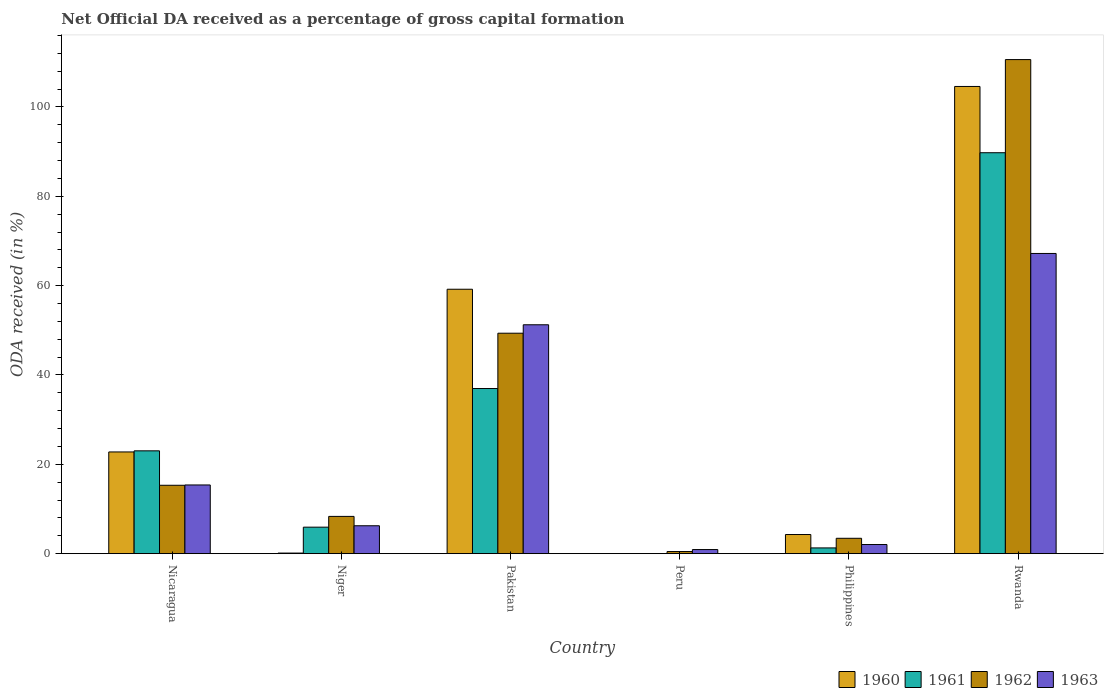How many different coloured bars are there?
Keep it short and to the point. 4. How many groups of bars are there?
Your response must be concise. 6. Are the number of bars per tick equal to the number of legend labels?
Offer a very short reply. No. How many bars are there on the 4th tick from the right?
Provide a short and direct response. 4. What is the label of the 1st group of bars from the left?
Provide a succinct answer. Nicaragua. In how many cases, is the number of bars for a given country not equal to the number of legend labels?
Give a very brief answer. 1. What is the net ODA received in 1963 in Philippines?
Offer a very short reply. 2.05. Across all countries, what is the maximum net ODA received in 1963?
Make the answer very short. 67.2. Across all countries, what is the minimum net ODA received in 1961?
Offer a terse response. 0. In which country was the net ODA received in 1961 maximum?
Keep it short and to the point. Rwanda. What is the total net ODA received in 1961 in the graph?
Offer a very short reply. 156.95. What is the difference between the net ODA received in 1963 in Nicaragua and that in Philippines?
Ensure brevity in your answer.  13.33. What is the difference between the net ODA received in 1961 in Philippines and the net ODA received in 1960 in Rwanda?
Your answer should be very brief. -103.3. What is the average net ODA received in 1963 per country?
Offer a very short reply. 23.84. What is the difference between the net ODA received of/in 1963 and net ODA received of/in 1961 in Nicaragua?
Offer a very short reply. -7.64. What is the ratio of the net ODA received in 1962 in Nicaragua to that in Rwanda?
Keep it short and to the point. 0.14. Is the net ODA received in 1963 in Pakistan less than that in Rwanda?
Your answer should be very brief. Yes. What is the difference between the highest and the second highest net ODA received in 1962?
Offer a terse response. -61.25. What is the difference between the highest and the lowest net ODA received in 1962?
Offer a terse response. 110.13. Is it the case that in every country, the sum of the net ODA received in 1961 and net ODA received in 1962 is greater than the sum of net ODA received in 1963 and net ODA received in 1960?
Provide a succinct answer. No. Is it the case that in every country, the sum of the net ODA received in 1961 and net ODA received in 1962 is greater than the net ODA received in 1963?
Offer a terse response. No. How many bars are there?
Keep it short and to the point. 22. Are all the bars in the graph horizontal?
Keep it short and to the point. No. How many countries are there in the graph?
Your answer should be very brief. 6. Are the values on the major ticks of Y-axis written in scientific E-notation?
Your response must be concise. No. Does the graph contain grids?
Make the answer very short. No. What is the title of the graph?
Your answer should be very brief. Net Official DA received as a percentage of gross capital formation. Does "1980" appear as one of the legend labels in the graph?
Your answer should be compact. No. What is the label or title of the X-axis?
Provide a succinct answer. Country. What is the label or title of the Y-axis?
Offer a very short reply. ODA received (in %). What is the ODA received (in %) of 1960 in Nicaragua?
Your answer should be compact. 22.77. What is the ODA received (in %) of 1961 in Nicaragua?
Offer a very short reply. 23.02. What is the ODA received (in %) of 1962 in Nicaragua?
Your answer should be very brief. 15.31. What is the ODA received (in %) in 1963 in Nicaragua?
Your response must be concise. 15.38. What is the ODA received (in %) in 1960 in Niger?
Provide a succinct answer. 0.13. What is the ODA received (in %) in 1961 in Niger?
Give a very brief answer. 5.93. What is the ODA received (in %) of 1962 in Niger?
Ensure brevity in your answer.  8.34. What is the ODA received (in %) in 1963 in Niger?
Provide a succinct answer. 6.25. What is the ODA received (in %) in 1960 in Pakistan?
Your answer should be compact. 59.19. What is the ODA received (in %) in 1961 in Pakistan?
Keep it short and to the point. 36.96. What is the ODA received (in %) of 1962 in Pakistan?
Provide a succinct answer. 49.35. What is the ODA received (in %) in 1963 in Pakistan?
Your answer should be compact. 51.24. What is the ODA received (in %) in 1962 in Peru?
Make the answer very short. 0.47. What is the ODA received (in %) of 1963 in Peru?
Provide a short and direct response. 0.92. What is the ODA received (in %) in 1960 in Philippines?
Ensure brevity in your answer.  4.28. What is the ODA received (in %) of 1961 in Philippines?
Make the answer very short. 1.29. What is the ODA received (in %) in 1962 in Philippines?
Provide a short and direct response. 3.44. What is the ODA received (in %) of 1963 in Philippines?
Give a very brief answer. 2.05. What is the ODA received (in %) in 1960 in Rwanda?
Make the answer very short. 104.58. What is the ODA received (in %) of 1961 in Rwanda?
Keep it short and to the point. 89.75. What is the ODA received (in %) of 1962 in Rwanda?
Your answer should be very brief. 110.6. What is the ODA received (in %) of 1963 in Rwanda?
Your answer should be compact. 67.2. Across all countries, what is the maximum ODA received (in %) of 1960?
Your answer should be very brief. 104.58. Across all countries, what is the maximum ODA received (in %) of 1961?
Make the answer very short. 89.75. Across all countries, what is the maximum ODA received (in %) of 1962?
Your answer should be compact. 110.6. Across all countries, what is the maximum ODA received (in %) of 1963?
Give a very brief answer. 67.2. Across all countries, what is the minimum ODA received (in %) in 1962?
Make the answer very short. 0.47. Across all countries, what is the minimum ODA received (in %) in 1963?
Provide a succinct answer. 0.92. What is the total ODA received (in %) of 1960 in the graph?
Offer a very short reply. 190.96. What is the total ODA received (in %) of 1961 in the graph?
Keep it short and to the point. 156.95. What is the total ODA received (in %) in 1962 in the graph?
Ensure brevity in your answer.  187.51. What is the total ODA received (in %) of 1963 in the graph?
Your answer should be very brief. 143.02. What is the difference between the ODA received (in %) of 1960 in Nicaragua and that in Niger?
Provide a succinct answer. 22.64. What is the difference between the ODA received (in %) in 1961 in Nicaragua and that in Niger?
Provide a succinct answer. 17.09. What is the difference between the ODA received (in %) in 1962 in Nicaragua and that in Niger?
Provide a succinct answer. 6.97. What is the difference between the ODA received (in %) in 1963 in Nicaragua and that in Niger?
Offer a terse response. 9.13. What is the difference between the ODA received (in %) of 1960 in Nicaragua and that in Pakistan?
Offer a very short reply. -36.42. What is the difference between the ODA received (in %) in 1961 in Nicaragua and that in Pakistan?
Your answer should be very brief. -13.95. What is the difference between the ODA received (in %) in 1962 in Nicaragua and that in Pakistan?
Provide a succinct answer. -34.04. What is the difference between the ODA received (in %) of 1963 in Nicaragua and that in Pakistan?
Your answer should be compact. -35.86. What is the difference between the ODA received (in %) in 1962 in Nicaragua and that in Peru?
Provide a short and direct response. 14.83. What is the difference between the ODA received (in %) of 1963 in Nicaragua and that in Peru?
Your answer should be very brief. 14.46. What is the difference between the ODA received (in %) of 1960 in Nicaragua and that in Philippines?
Your response must be concise. 18.48. What is the difference between the ODA received (in %) of 1961 in Nicaragua and that in Philippines?
Offer a very short reply. 21.73. What is the difference between the ODA received (in %) in 1962 in Nicaragua and that in Philippines?
Your answer should be very brief. 11.87. What is the difference between the ODA received (in %) in 1963 in Nicaragua and that in Philippines?
Offer a terse response. 13.33. What is the difference between the ODA received (in %) of 1960 in Nicaragua and that in Rwanda?
Provide a succinct answer. -81.81. What is the difference between the ODA received (in %) in 1961 in Nicaragua and that in Rwanda?
Your answer should be very brief. -66.73. What is the difference between the ODA received (in %) in 1962 in Nicaragua and that in Rwanda?
Provide a short and direct response. -95.29. What is the difference between the ODA received (in %) of 1963 in Nicaragua and that in Rwanda?
Offer a terse response. -51.82. What is the difference between the ODA received (in %) in 1960 in Niger and that in Pakistan?
Provide a short and direct response. -59.06. What is the difference between the ODA received (in %) of 1961 in Niger and that in Pakistan?
Keep it short and to the point. -31.03. What is the difference between the ODA received (in %) of 1962 in Niger and that in Pakistan?
Provide a short and direct response. -41.01. What is the difference between the ODA received (in %) in 1963 in Niger and that in Pakistan?
Your answer should be compact. -44.99. What is the difference between the ODA received (in %) of 1962 in Niger and that in Peru?
Your answer should be very brief. 7.87. What is the difference between the ODA received (in %) in 1963 in Niger and that in Peru?
Ensure brevity in your answer.  5.33. What is the difference between the ODA received (in %) in 1960 in Niger and that in Philippines?
Keep it short and to the point. -4.15. What is the difference between the ODA received (in %) of 1961 in Niger and that in Philippines?
Offer a very short reply. 4.64. What is the difference between the ODA received (in %) in 1962 in Niger and that in Philippines?
Provide a short and direct response. 4.9. What is the difference between the ODA received (in %) of 1963 in Niger and that in Philippines?
Your answer should be compact. 4.2. What is the difference between the ODA received (in %) in 1960 in Niger and that in Rwanda?
Make the answer very short. -104.45. What is the difference between the ODA received (in %) in 1961 in Niger and that in Rwanda?
Give a very brief answer. -83.82. What is the difference between the ODA received (in %) in 1962 in Niger and that in Rwanda?
Give a very brief answer. -102.26. What is the difference between the ODA received (in %) of 1963 in Niger and that in Rwanda?
Your answer should be compact. -60.95. What is the difference between the ODA received (in %) in 1962 in Pakistan and that in Peru?
Make the answer very short. 48.87. What is the difference between the ODA received (in %) of 1963 in Pakistan and that in Peru?
Offer a terse response. 50.32. What is the difference between the ODA received (in %) of 1960 in Pakistan and that in Philippines?
Provide a succinct answer. 54.9. What is the difference between the ODA received (in %) of 1961 in Pakistan and that in Philippines?
Ensure brevity in your answer.  35.68. What is the difference between the ODA received (in %) of 1962 in Pakistan and that in Philippines?
Keep it short and to the point. 45.91. What is the difference between the ODA received (in %) of 1963 in Pakistan and that in Philippines?
Your answer should be compact. 49.19. What is the difference between the ODA received (in %) in 1960 in Pakistan and that in Rwanda?
Offer a terse response. -45.39. What is the difference between the ODA received (in %) of 1961 in Pakistan and that in Rwanda?
Make the answer very short. -52.79. What is the difference between the ODA received (in %) in 1962 in Pakistan and that in Rwanda?
Ensure brevity in your answer.  -61.25. What is the difference between the ODA received (in %) in 1963 in Pakistan and that in Rwanda?
Your answer should be very brief. -15.96. What is the difference between the ODA received (in %) of 1962 in Peru and that in Philippines?
Make the answer very short. -2.97. What is the difference between the ODA received (in %) of 1963 in Peru and that in Philippines?
Give a very brief answer. -1.13. What is the difference between the ODA received (in %) in 1962 in Peru and that in Rwanda?
Provide a short and direct response. -110.13. What is the difference between the ODA received (in %) in 1963 in Peru and that in Rwanda?
Provide a succinct answer. -66.28. What is the difference between the ODA received (in %) in 1960 in Philippines and that in Rwanda?
Provide a short and direct response. -100.3. What is the difference between the ODA received (in %) of 1961 in Philippines and that in Rwanda?
Offer a terse response. -88.46. What is the difference between the ODA received (in %) in 1962 in Philippines and that in Rwanda?
Provide a succinct answer. -107.16. What is the difference between the ODA received (in %) of 1963 in Philippines and that in Rwanda?
Provide a succinct answer. -65.15. What is the difference between the ODA received (in %) of 1960 in Nicaragua and the ODA received (in %) of 1961 in Niger?
Offer a very short reply. 16.84. What is the difference between the ODA received (in %) in 1960 in Nicaragua and the ODA received (in %) in 1962 in Niger?
Your answer should be compact. 14.43. What is the difference between the ODA received (in %) in 1960 in Nicaragua and the ODA received (in %) in 1963 in Niger?
Make the answer very short. 16.52. What is the difference between the ODA received (in %) in 1961 in Nicaragua and the ODA received (in %) in 1962 in Niger?
Keep it short and to the point. 14.68. What is the difference between the ODA received (in %) of 1961 in Nicaragua and the ODA received (in %) of 1963 in Niger?
Provide a succinct answer. 16.77. What is the difference between the ODA received (in %) in 1962 in Nicaragua and the ODA received (in %) in 1963 in Niger?
Offer a terse response. 9.06. What is the difference between the ODA received (in %) of 1960 in Nicaragua and the ODA received (in %) of 1961 in Pakistan?
Make the answer very short. -14.2. What is the difference between the ODA received (in %) of 1960 in Nicaragua and the ODA received (in %) of 1962 in Pakistan?
Keep it short and to the point. -26.58. What is the difference between the ODA received (in %) of 1960 in Nicaragua and the ODA received (in %) of 1963 in Pakistan?
Your response must be concise. -28.47. What is the difference between the ODA received (in %) in 1961 in Nicaragua and the ODA received (in %) in 1962 in Pakistan?
Make the answer very short. -26.33. What is the difference between the ODA received (in %) in 1961 in Nicaragua and the ODA received (in %) in 1963 in Pakistan?
Provide a short and direct response. -28.22. What is the difference between the ODA received (in %) in 1962 in Nicaragua and the ODA received (in %) in 1963 in Pakistan?
Your response must be concise. -35.93. What is the difference between the ODA received (in %) in 1960 in Nicaragua and the ODA received (in %) in 1962 in Peru?
Provide a short and direct response. 22.29. What is the difference between the ODA received (in %) in 1960 in Nicaragua and the ODA received (in %) in 1963 in Peru?
Your answer should be very brief. 21.85. What is the difference between the ODA received (in %) of 1961 in Nicaragua and the ODA received (in %) of 1962 in Peru?
Provide a succinct answer. 22.54. What is the difference between the ODA received (in %) of 1961 in Nicaragua and the ODA received (in %) of 1963 in Peru?
Ensure brevity in your answer.  22.1. What is the difference between the ODA received (in %) in 1962 in Nicaragua and the ODA received (in %) in 1963 in Peru?
Offer a terse response. 14.39. What is the difference between the ODA received (in %) in 1960 in Nicaragua and the ODA received (in %) in 1961 in Philippines?
Keep it short and to the point. 21.48. What is the difference between the ODA received (in %) in 1960 in Nicaragua and the ODA received (in %) in 1962 in Philippines?
Give a very brief answer. 19.33. What is the difference between the ODA received (in %) of 1960 in Nicaragua and the ODA received (in %) of 1963 in Philippines?
Your answer should be very brief. 20.72. What is the difference between the ODA received (in %) in 1961 in Nicaragua and the ODA received (in %) in 1962 in Philippines?
Your answer should be very brief. 19.58. What is the difference between the ODA received (in %) of 1961 in Nicaragua and the ODA received (in %) of 1963 in Philippines?
Your response must be concise. 20.97. What is the difference between the ODA received (in %) of 1962 in Nicaragua and the ODA received (in %) of 1963 in Philippines?
Offer a terse response. 13.26. What is the difference between the ODA received (in %) of 1960 in Nicaragua and the ODA received (in %) of 1961 in Rwanda?
Offer a terse response. -66.98. What is the difference between the ODA received (in %) in 1960 in Nicaragua and the ODA received (in %) in 1962 in Rwanda?
Ensure brevity in your answer.  -87.83. What is the difference between the ODA received (in %) of 1960 in Nicaragua and the ODA received (in %) of 1963 in Rwanda?
Give a very brief answer. -44.43. What is the difference between the ODA received (in %) of 1961 in Nicaragua and the ODA received (in %) of 1962 in Rwanda?
Ensure brevity in your answer.  -87.58. What is the difference between the ODA received (in %) of 1961 in Nicaragua and the ODA received (in %) of 1963 in Rwanda?
Your answer should be compact. -44.18. What is the difference between the ODA received (in %) in 1962 in Nicaragua and the ODA received (in %) in 1963 in Rwanda?
Your answer should be very brief. -51.89. What is the difference between the ODA received (in %) of 1960 in Niger and the ODA received (in %) of 1961 in Pakistan?
Provide a succinct answer. -36.83. What is the difference between the ODA received (in %) of 1960 in Niger and the ODA received (in %) of 1962 in Pakistan?
Your answer should be very brief. -49.21. What is the difference between the ODA received (in %) in 1960 in Niger and the ODA received (in %) in 1963 in Pakistan?
Keep it short and to the point. -51.1. What is the difference between the ODA received (in %) in 1961 in Niger and the ODA received (in %) in 1962 in Pakistan?
Provide a short and direct response. -43.42. What is the difference between the ODA received (in %) in 1961 in Niger and the ODA received (in %) in 1963 in Pakistan?
Keep it short and to the point. -45.31. What is the difference between the ODA received (in %) in 1962 in Niger and the ODA received (in %) in 1963 in Pakistan?
Provide a short and direct response. -42.9. What is the difference between the ODA received (in %) in 1960 in Niger and the ODA received (in %) in 1962 in Peru?
Your response must be concise. -0.34. What is the difference between the ODA received (in %) of 1960 in Niger and the ODA received (in %) of 1963 in Peru?
Your answer should be compact. -0.78. What is the difference between the ODA received (in %) of 1961 in Niger and the ODA received (in %) of 1962 in Peru?
Ensure brevity in your answer.  5.46. What is the difference between the ODA received (in %) of 1961 in Niger and the ODA received (in %) of 1963 in Peru?
Make the answer very short. 5.01. What is the difference between the ODA received (in %) in 1962 in Niger and the ODA received (in %) in 1963 in Peru?
Provide a short and direct response. 7.42. What is the difference between the ODA received (in %) in 1960 in Niger and the ODA received (in %) in 1961 in Philippines?
Offer a terse response. -1.15. What is the difference between the ODA received (in %) in 1960 in Niger and the ODA received (in %) in 1962 in Philippines?
Your answer should be very brief. -3.31. What is the difference between the ODA received (in %) in 1960 in Niger and the ODA received (in %) in 1963 in Philippines?
Offer a terse response. -1.91. What is the difference between the ODA received (in %) in 1961 in Niger and the ODA received (in %) in 1962 in Philippines?
Give a very brief answer. 2.49. What is the difference between the ODA received (in %) in 1961 in Niger and the ODA received (in %) in 1963 in Philippines?
Keep it short and to the point. 3.88. What is the difference between the ODA received (in %) in 1962 in Niger and the ODA received (in %) in 1963 in Philippines?
Provide a short and direct response. 6.29. What is the difference between the ODA received (in %) in 1960 in Niger and the ODA received (in %) in 1961 in Rwanda?
Offer a terse response. -89.62. What is the difference between the ODA received (in %) in 1960 in Niger and the ODA received (in %) in 1962 in Rwanda?
Keep it short and to the point. -110.47. What is the difference between the ODA received (in %) in 1960 in Niger and the ODA received (in %) in 1963 in Rwanda?
Your answer should be compact. -67.07. What is the difference between the ODA received (in %) in 1961 in Niger and the ODA received (in %) in 1962 in Rwanda?
Offer a very short reply. -104.67. What is the difference between the ODA received (in %) of 1961 in Niger and the ODA received (in %) of 1963 in Rwanda?
Provide a short and direct response. -61.27. What is the difference between the ODA received (in %) in 1962 in Niger and the ODA received (in %) in 1963 in Rwanda?
Provide a short and direct response. -58.86. What is the difference between the ODA received (in %) in 1960 in Pakistan and the ODA received (in %) in 1962 in Peru?
Provide a short and direct response. 58.71. What is the difference between the ODA received (in %) in 1960 in Pakistan and the ODA received (in %) in 1963 in Peru?
Provide a succinct answer. 58.27. What is the difference between the ODA received (in %) of 1961 in Pakistan and the ODA received (in %) of 1962 in Peru?
Your answer should be compact. 36.49. What is the difference between the ODA received (in %) of 1961 in Pakistan and the ODA received (in %) of 1963 in Peru?
Provide a succinct answer. 36.05. What is the difference between the ODA received (in %) of 1962 in Pakistan and the ODA received (in %) of 1963 in Peru?
Offer a terse response. 48.43. What is the difference between the ODA received (in %) of 1960 in Pakistan and the ODA received (in %) of 1961 in Philippines?
Provide a short and direct response. 57.9. What is the difference between the ODA received (in %) of 1960 in Pakistan and the ODA received (in %) of 1962 in Philippines?
Your response must be concise. 55.75. What is the difference between the ODA received (in %) of 1960 in Pakistan and the ODA received (in %) of 1963 in Philippines?
Provide a short and direct response. 57.14. What is the difference between the ODA received (in %) of 1961 in Pakistan and the ODA received (in %) of 1962 in Philippines?
Give a very brief answer. 33.52. What is the difference between the ODA received (in %) of 1961 in Pakistan and the ODA received (in %) of 1963 in Philippines?
Give a very brief answer. 34.92. What is the difference between the ODA received (in %) in 1962 in Pakistan and the ODA received (in %) in 1963 in Philippines?
Offer a very short reply. 47.3. What is the difference between the ODA received (in %) in 1960 in Pakistan and the ODA received (in %) in 1961 in Rwanda?
Offer a terse response. -30.56. What is the difference between the ODA received (in %) in 1960 in Pakistan and the ODA received (in %) in 1962 in Rwanda?
Your answer should be very brief. -51.41. What is the difference between the ODA received (in %) in 1960 in Pakistan and the ODA received (in %) in 1963 in Rwanda?
Offer a very short reply. -8.01. What is the difference between the ODA received (in %) in 1961 in Pakistan and the ODA received (in %) in 1962 in Rwanda?
Offer a very short reply. -73.64. What is the difference between the ODA received (in %) of 1961 in Pakistan and the ODA received (in %) of 1963 in Rwanda?
Give a very brief answer. -30.24. What is the difference between the ODA received (in %) in 1962 in Pakistan and the ODA received (in %) in 1963 in Rwanda?
Offer a very short reply. -17.85. What is the difference between the ODA received (in %) in 1962 in Peru and the ODA received (in %) in 1963 in Philippines?
Your response must be concise. -1.57. What is the difference between the ODA received (in %) of 1962 in Peru and the ODA received (in %) of 1963 in Rwanda?
Your response must be concise. -66.73. What is the difference between the ODA received (in %) in 1960 in Philippines and the ODA received (in %) in 1961 in Rwanda?
Provide a short and direct response. -85.47. What is the difference between the ODA received (in %) of 1960 in Philippines and the ODA received (in %) of 1962 in Rwanda?
Ensure brevity in your answer.  -106.32. What is the difference between the ODA received (in %) in 1960 in Philippines and the ODA received (in %) in 1963 in Rwanda?
Offer a terse response. -62.92. What is the difference between the ODA received (in %) of 1961 in Philippines and the ODA received (in %) of 1962 in Rwanda?
Give a very brief answer. -109.31. What is the difference between the ODA received (in %) in 1961 in Philippines and the ODA received (in %) in 1963 in Rwanda?
Your response must be concise. -65.91. What is the difference between the ODA received (in %) of 1962 in Philippines and the ODA received (in %) of 1963 in Rwanda?
Offer a terse response. -63.76. What is the average ODA received (in %) in 1960 per country?
Offer a terse response. 31.83. What is the average ODA received (in %) in 1961 per country?
Provide a short and direct response. 26.16. What is the average ODA received (in %) in 1962 per country?
Give a very brief answer. 31.25. What is the average ODA received (in %) in 1963 per country?
Make the answer very short. 23.84. What is the difference between the ODA received (in %) in 1960 and ODA received (in %) in 1961 in Nicaragua?
Ensure brevity in your answer.  -0.25. What is the difference between the ODA received (in %) of 1960 and ODA received (in %) of 1962 in Nicaragua?
Give a very brief answer. 7.46. What is the difference between the ODA received (in %) in 1960 and ODA received (in %) in 1963 in Nicaragua?
Your answer should be compact. 7.39. What is the difference between the ODA received (in %) of 1961 and ODA received (in %) of 1962 in Nicaragua?
Give a very brief answer. 7.71. What is the difference between the ODA received (in %) of 1961 and ODA received (in %) of 1963 in Nicaragua?
Your answer should be compact. 7.64. What is the difference between the ODA received (in %) of 1962 and ODA received (in %) of 1963 in Nicaragua?
Provide a short and direct response. -0.07. What is the difference between the ODA received (in %) of 1960 and ODA received (in %) of 1961 in Niger?
Offer a very short reply. -5.8. What is the difference between the ODA received (in %) of 1960 and ODA received (in %) of 1962 in Niger?
Provide a succinct answer. -8.21. What is the difference between the ODA received (in %) in 1960 and ODA received (in %) in 1963 in Niger?
Ensure brevity in your answer.  -6.11. What is the difference between the ODA received (in %) of 1961 and ODA received (in %) of 1962 in Niger?
Ensure brevity in your answer.  -2.41. What is the difference between the ODA received (in %) in 1961 and ODA received (in %) in 1963 in Niger?
Your response must be concise. -0.32. What is the difference between the ODA received (in %) of 1962 and ODA received (in %) of 1963 in Niger?
Provide a short and direct response. 2.09. What is the difference between the ODA received (in %) of 1960 and ODA received (in %) of 1961 in Pakistan?
Offer a very short reply. 22.22. What is the difference between the ODA received (in %) of 1960 and ODA received (in %) of 1962 in Pakistan?
Your response must be concise. 9.84. What is the difference between the ODA received (in %) in 1960 and ODA received (in %) in 1963 in Pakistan?
Give a very brief answer. 7.95. What is the difference between the ODA received (in %) in 1961 and ODA received (in %) in 1962 in Pakistan?
Make the answer very short. -12.38. What is the difference between the ODA received (in %) of 1961 and ODA received (in %) of 1963 in Pakistan?
Keep it short and to the point. -14.27. What is the difference between the ODA received (in %) of 1962 and ODA received (in %) of 1963 in Pakistan?
Ensure brevity in your answer.  -1.89. What is the difference between the ODA received (in %) in 1962 and ODA received (in %) in 1963 in Peru?
Offer a terse response. -0.44. What is the difference between the ODA received (in %) of 1960 and ODA received (in %) of 1961 in Philippines?
Provide a short and direct response. 3. What is the difference between the ODA received (in %) in 1960 and ODA received (in %) in 1962 in Philippines?
Provide a short and direct response. 0.84. What is the difference between the ODA received (in %) in 1960 and ODA received (in %) in 1963 in Philippines?
Offer a terse response. 2.24. What is the difference between the ODA received (in %) in 1961 and ODA received (in %) in 1962 in Philippines?
Give a very brief answer. -2.15. What is the difference between the ODA received (in %) of 1961 and ODA received (in %) of 1963 in Philippines?
Provide a short and direct response. -0.76. What is the difference between the ODA received (in %) of 1962 and ODA received (in %) of 1963 in Philippines?
Offer a terse response. 1.4. What is the difference between the ODA received (in %) of 1960 and ODA received (in %) of 1961 in Rwanda?
Give a very brief answer. 14.83. What is the difference between the ODA received (in %) in 1960 and ODA received (in %) in 1962 in Rwanda?
Offer a very short reply. -6.02. What is the difference between the ODA received (in %) of 1960 and ODA received (in %) of 1963 in Rwanda?
Provide a succinct answer. 37.38. What is the difference between the ODA received (in %) in 1961 and ODA received (in %) in 1962 in Rwanda?
Make the answer very short. -20.85. What is the difference between the ODA received (in %) in 1961 and ODA received (in %) in 1963 in Rwanda?
Provide a succinct answer. 22.55. What is the difference between the ODA received (in %) of 1962 and ODA received (in %) of 1963 in Rwanda?
Your answer should be very brief. 43.4. What is the ratio of the ODA received (in %) of 1960 in Nicaragua to that in Niger?
Your response must be concise. 171.32. What is the ratio of the ODA received (in %) in 1961 in Nicaragua to that in Niger?
Your response must be concise. 3.88. What is the ratio of the ODA received (in %) of 1962 in Nicaragua to that in Niger?
Offer a very short reply. 1.84. What is the ratio of the ODA received (in %) in 1963 in Nicaragua to that in Niger?
Provide a short and direct response. 2.46. What is the ratio of the ODA received (in %) in 1960 in Nicaragua to that in Pakistan?
Your response must be concise. 0.38. What is the ratio of the ODA received (in %) of 1961 in Nicaragua to that in Pakistan?
Your answer should be very brief. 0.62. What is the ratio of the ODA received (in %) in 1962 in Nicaragua to that in Pakistan?
Ensure brevity in your answer.  0.31. What is the ratio of the ODA received (in %) of 1963 in Nicaragua to that in Pakistan?
Your answer should be very brief. 0.3. What is the ratio of the ODA received (in %) in 1962 in Nicaragua to that in Peru?
Ensure brevity in your answer.  32.28. What is the ratio of the ODA received (in %) in 1963 in Nicaragua to that in Peru?
Your answer should be very brief. 16.76. What is the ratio of the ODA received (in %) in 1960 in Nicaragua to that in Philippines?
Your answer should be very brief. 5.31. What is the ratio of the ODA received (in %) in 1961 in Nicaragua to that in Philippines?
Offer a terse response. 17.88. What is the ratio of the ODA received (in %) in 1962 in Nicaragua to that in Philippines?
Offer a very short reply. 4.45. What is the ratio of the ODA received (in %) of 1963 in Nicaragua to that in Philippines?
Give a very brief answer. 7.52. What is the ratio of the ODA received (in %) in 1960 in Nicaragua to that in Rwanda?
Keep it short and to the point. 0.22. What is the ratio of the ODA received (in %) in 1961 in Nicaragua to that in Rwanda?
Your answer should be compact. 0.26. What is the ratio of the ODA received (in %) in 1962 in Nicaragua to that in Rwanda?
Your answer should be compact. 0.14. What is the ratio of the ODA received (in %) of 1963 in Nicaragua to that in Rwanda?
Offer a very short reply. 0.23. What is the ratio of the ODA received (in %) of 1960 in Niger to that in Pakistan?
Provide a short and direct response. 0. What is the ratio of the ODA received (in %) in 1961 in Niger to that in Pakistan?
Your answer should be compact. 0.16. What is the ratio of the ODA received (in %) in 1962 in Niger to that in Pakistan?
Your answer should be very brief. 0.17. What is the ratio of the ODA received (in %) in 1963 in Niger to that in Pakistan?
Give a very brief answer. 0.12. What is the ratio of the ODA received (in %) of 1962 in Niger to that in Peru?
Provide a succinct answer. 17.59. What is the ratio of the ODA received (in %) in 1963 in Niger to that in Peru?
Provide a short and direct response. 6.81. What is the ratio of the ODA received (in %) in 1960 in Niger to that in Philippines?
Your response must be concise. 0.03. What is the ratio of the ODA received (in %) of 1961 in Niger to that in Philippines?
Your answer should be very brief. 4.61. What is the ratio of the ODA received (in %) of 1962 in Niger to that in Philippines?
Your answer should be very brief. 2.42. What is the ratio of the ODA received (in %) in 1963 in Niger to that in Philippines?
Your response must be concise. 3.05. What is the ratio of the ODA received (in %) of 1960 in Niger to that in Rwanda?
Your response must be concise. 0. What is the ratio of the ODA received (in %) of 1961 in Niger to that in Rwanda?
Provide a short and direct response. 0.07. What is the ratio of the ODA received (in %) of 1962 in Niger to that in Rwanda?
Provide a short and direct response. 0.08. What is the ratio of the ODA received (in %) of 1963 in Niger to that in Rwanda?
Provide a short and direct response. 0.09. What is the ratio of the ODA received (in %) of 1962 in Pakistan to that in Peru?
Give a very brief answer. 104.06. What is the ratio of the ODA received (in %) of 1963 in Pakistan to that in Peru?
Offer a terse response. 55.85. What is the ratio of the ODA received (in %) of 1960 in Pakistan to that in Philippines?
Provide a short and direct response. 13.82. What is the ratio of the ODA received (in %) of 1961 in Pakistan to that in Philippines?
Ensure brevity in your answer.  28.71. What is the ratio of the ODA received (in %) of 1962 in Pakistan to that in Philippines?
Your response must be concise. 14.34. What is the ratio of the ODA received (in %) in 1963 in Pakistan to that in Philippines?
Make the answer very short. 25.04. What is the ratio of the ODA received (in %) in 1960 in Pakistan to that in Rwanda?
Your response must be concise. 0.57. What is the ratio of the ODA received (in %) of 1961 in Pakistan to that in Rwanda?
Ensure brevity in your answer.  0.41. What is the ratio of the ODA received (in %) of 1962 in Pakistan to that in Rwanda?
Ensure brevity in your answer.  0.45. What is the ratio of the ODA received (in %) in 1963 in Pakistan to that in Rwanda?
Your response must be concise. 0.76. What is the ratio of the ODA received (in %) in 1962 in Peru to that in Philippines?
Offer a very short reply. 0.14. What is the ratio of the ODA received (in %) of 1963 in Peru to that in Philippines?
Give a very brief answer. 0.45. What is the ratio of the ODA received (in %) in 1962 in Peru to that in Rwanda?
Provide a short and direct response. 0. What is the ratio of the ODA received (in %) in 1963 in Peru to that in Rwanda?
Provide a succinct answer. 0.01. What is the ratio of the ODA received (in %) of 1960 in Philippines to that in Rwanda?
Your answer should be compact. 0.04. What is the ratio of the ODA received (in %) of 1961 in Philippines to that in Rwanda?
Provide a short and direct response. 0.01. What is the ratio of the ODA received (in %) of 1962 in Philippines to that in Rwanda?
Your answer should be very brief. 0.03. What is the ratio of the ODA received (in %) in 1963 in Philippines to that in Rwanda?
Ensure brevity in your answer.  0.03. What is the difference between the highest and the second highest ODA received (in %) in 1960?
Keep it short and to the point. 45.39. What is the difference between the highest and the second highest ODA received (in %) of 1961?
Your answer should be compact. 52.79. What is the difference between the highest and the second highest ODA received (in %) of 1962?
Make the answer very short. 61.25. What is the difference between the highest and the second highest ODA received (in %) of 1963?
Provide a succinct answer. 15.96. What is the difference between the highest and the lowest ODA received (in %) in 1960?
Your answer should be very brief. 104.58. What is the difference between the highest and the lowest ODA received (in %) in 1961?
Your response must be concise. 89.75. What is the difference between the highest and the lowest ODA received (in %) of 1962?
Give a very brief answer. 110.13. What is the difference between the highest and the lowest ODA received (in %) in 1963?
Ensure brevity in your answer.  66.28. 